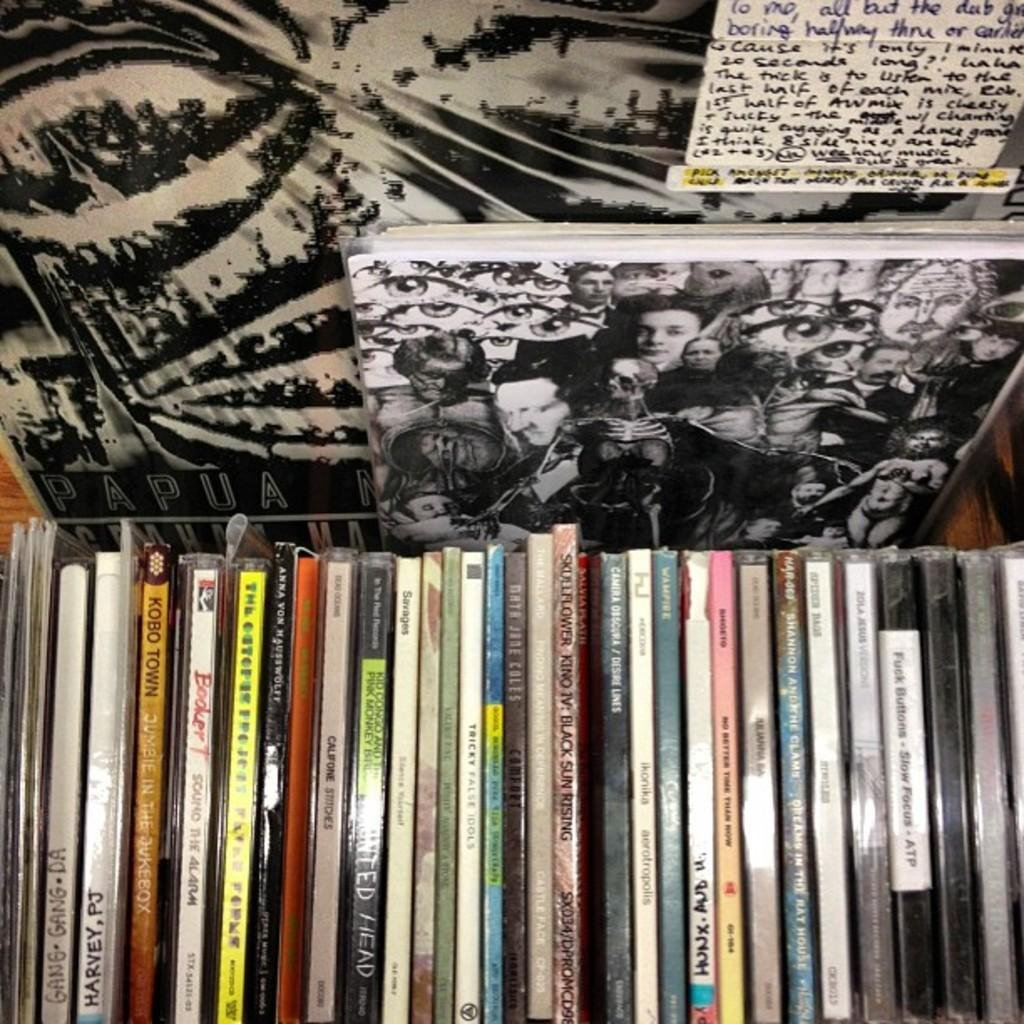What objects are present in the image related to reading or learning? There are books in the image, which are in a rack, and there is also a paper with something written on it. What is the color of the board in the image? The board in the image is white and black. Can you describe the arrangement of the books in the image? The books are in a rack, which suggests they are organized and easily accessible. What type of nest can be seen in the image? There is no nest present in the image. How does the thunder sound in the image? There is no thunder present in the image. 